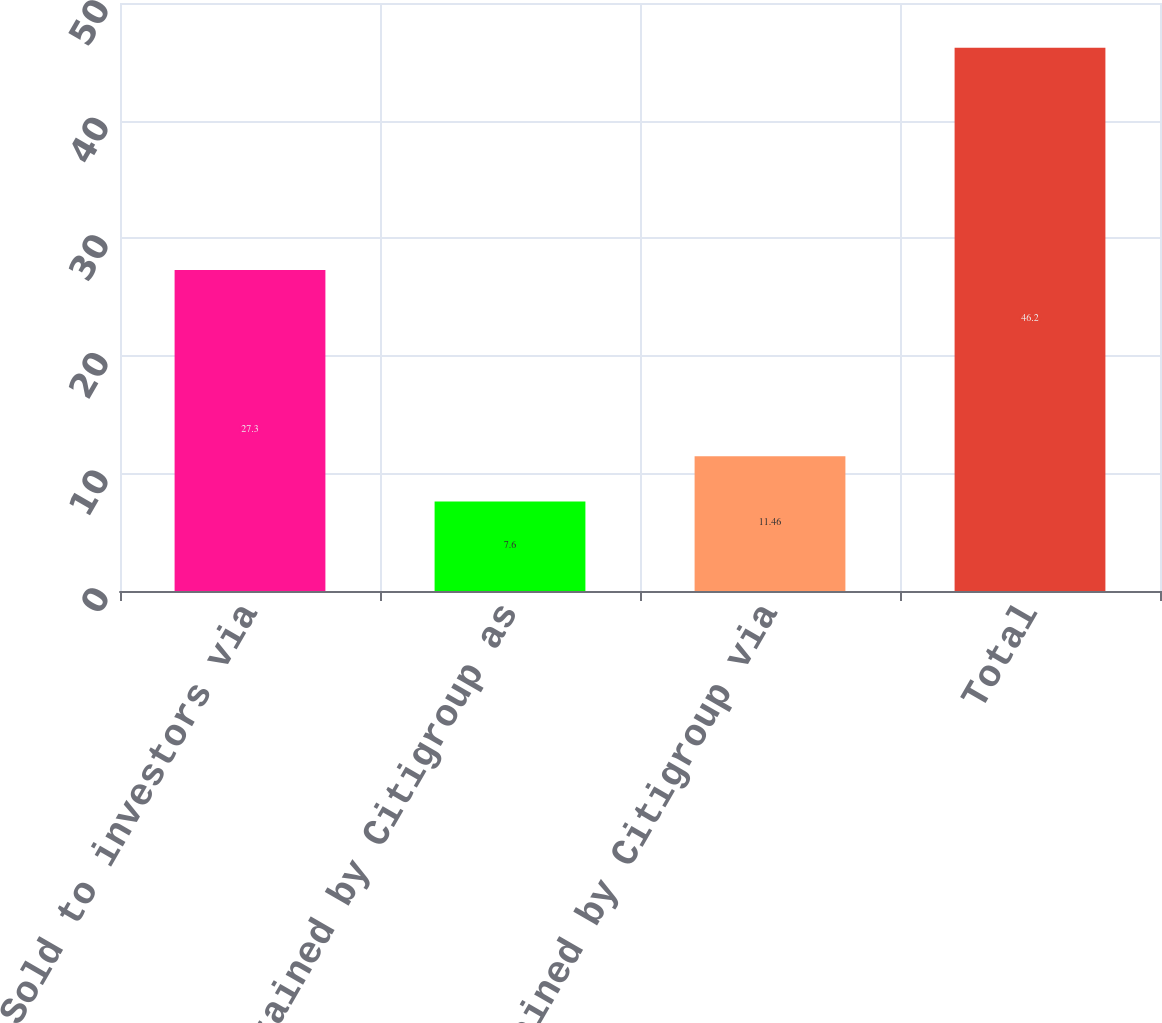<chart> <loc_0><loc_0><loc_500><loc_500><bar_chart><fcel>Sold to investors via<fcel>Retained by Citigroup as<fcel>Retained by Citigroup via<fcel>Total<nl><fcel>27.3<fcel>7.6<fcel>11.46<fcel>46.2<nl></chart> 